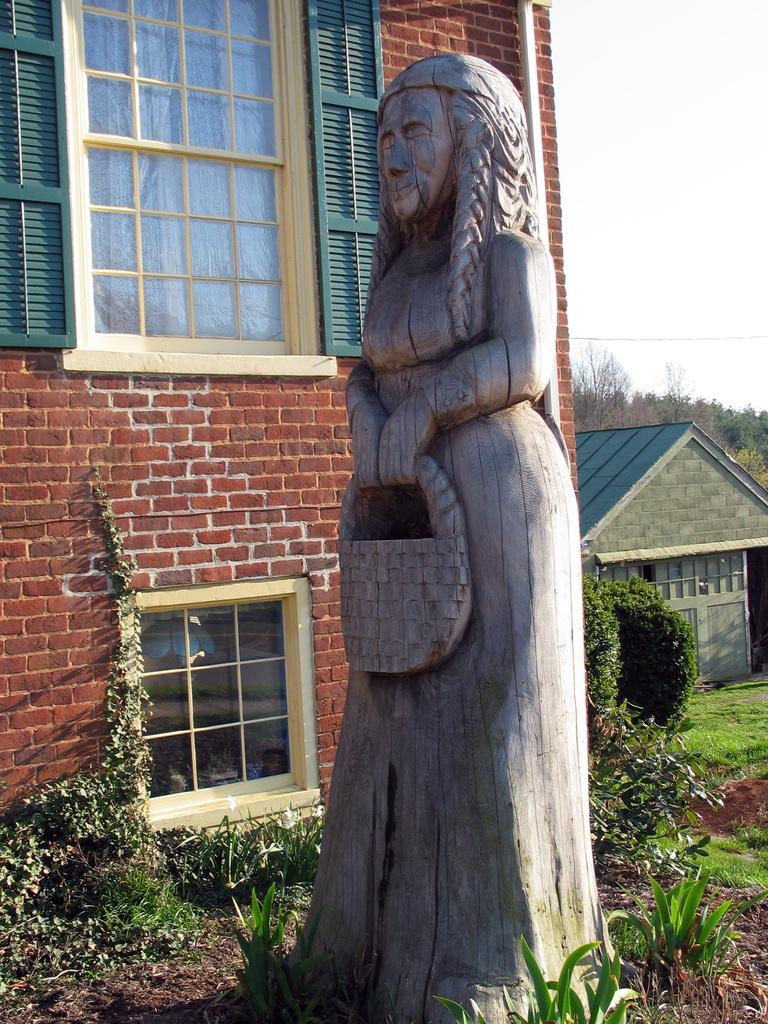What can be seen in the foreground of the picture? There are plants, soil, and a sculpture in the foreground of the picture. What is located in the middle of the picture? There are buildings and trees in the middle of the picture. What is visible in the background of the picture? The sky is visible in the background towards the right of the picture. How many beds are visible in the picture? There are no beds present in the picture. Can you see an airport in the picture? There is no airport visible in the picture. 